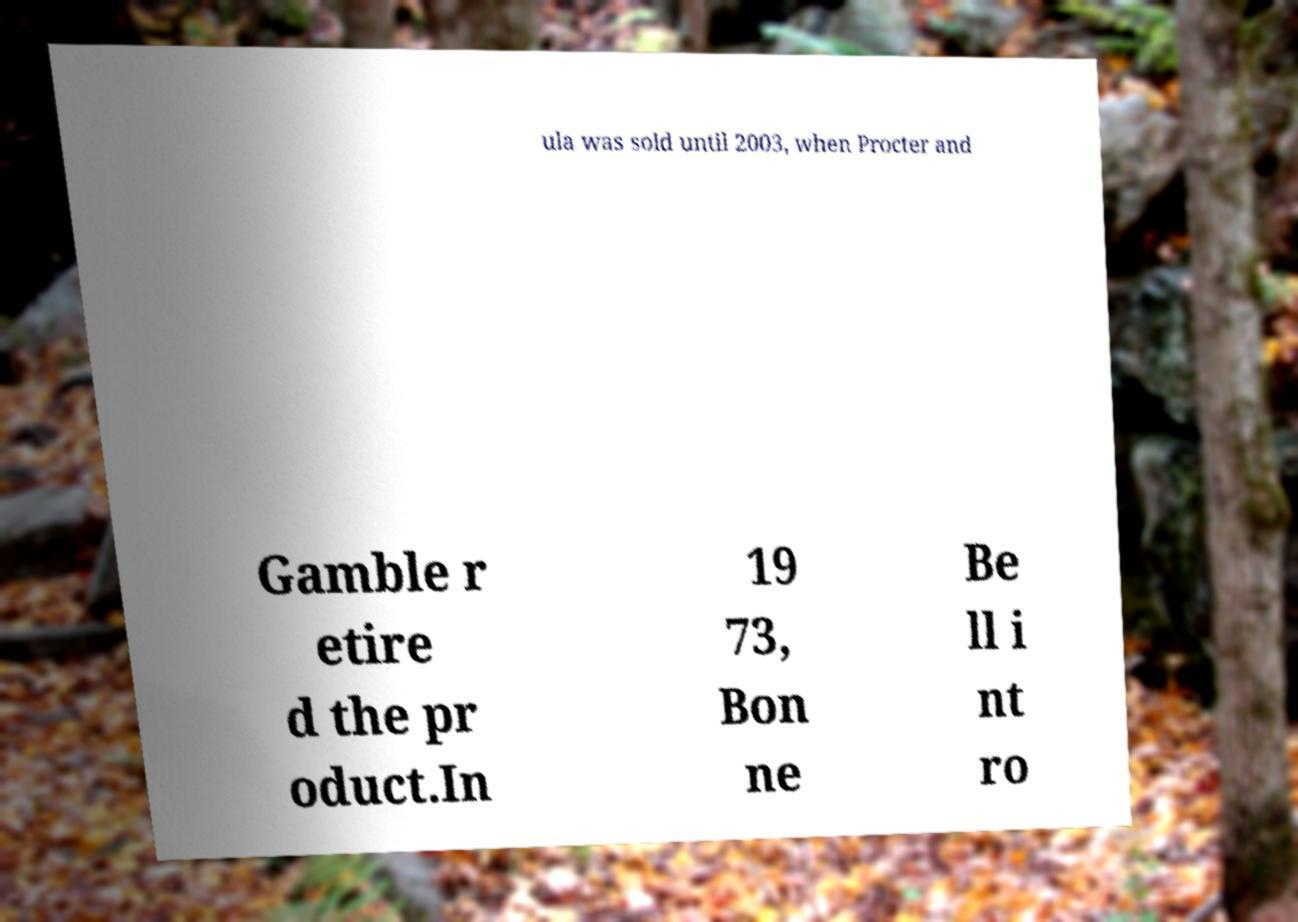I need the written content from this picture converted into text. Can you do that? ula was sold until 2003, when Procter and Gamble r etire d the pr oduct.In 19 73, Bon ne Be ll i nt ro 